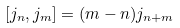Convert formula to latex. <formula><loc_0><loc_0><loc_500><loc_500>[ j _ { n } , j _ { m } ] = ( m - n ) j _ { n + m }</formula> 